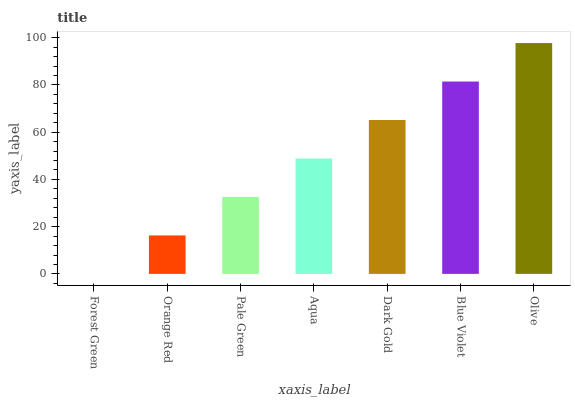Is Forest Green the minimum?
Answer yes or no. Yes. Is Olive the maximum?
Answer yes or no. Yes. Is Orange Red the minimum?
Answer yes or no. No. Is Orange Red the maximum?
Answer yes or no. No. Is Orange Red greater than Forest Green?
Answer yes or no. Yes. Is Forest Green less than Orange Red?
Answer yes or no. Yes. Is Forest Green greater than Orange Red?
Answer yes or no. No. Is Orange Red less than Forest Green?
Answer yes or no. No. Is Aqua the high median?
Answer yes or no. Yes. Is Aqua the low median?
Answer yes or no. Yes. Is Olive the high median?
Answer yes or no. No. Is Forest Green the low median?
Answer yes or no. No. 